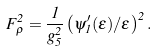Convert formula to latex. <formula><loc_0><loc_0><loc_500><loc_500>F _ { \rho } ^ { 2 } = \frac { 1 } { g _ { 5 } ^ { 2 } } \left ( \psi _ { 1 } ^ { \prime } ( \epsilon ) / \epsilon \right ) ^ { 2 } .</formula> 